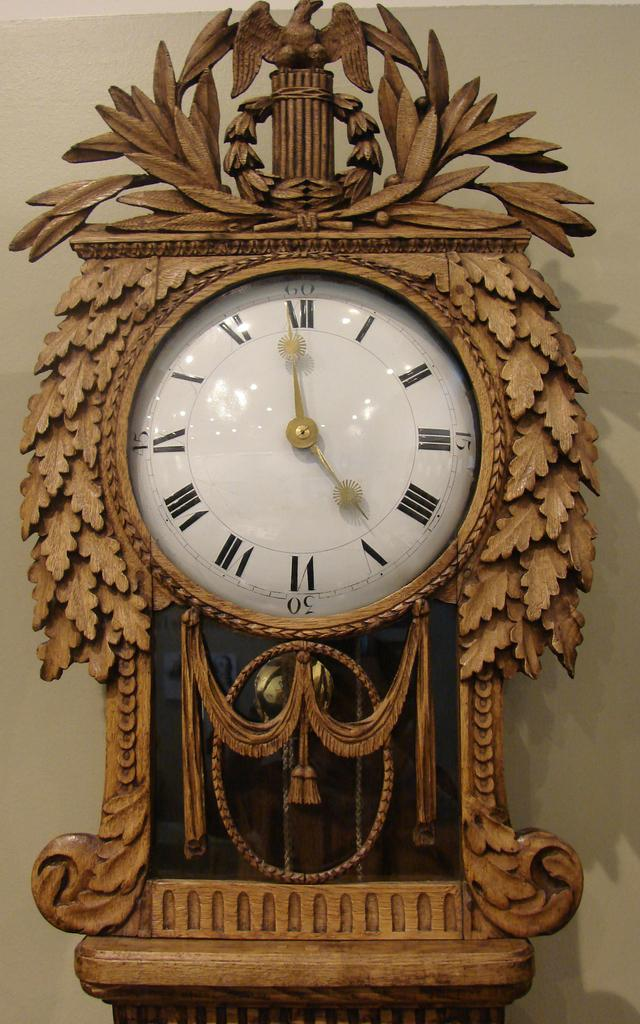What type of clock is in the image? There is a pendulum clock in the image. How is the pendulum clock attached to the wall? The pendulum clock is attached to the wall. What type of net can be seen in the image? There is no net present in the image; it features a pendulum clock attached to the wall. 